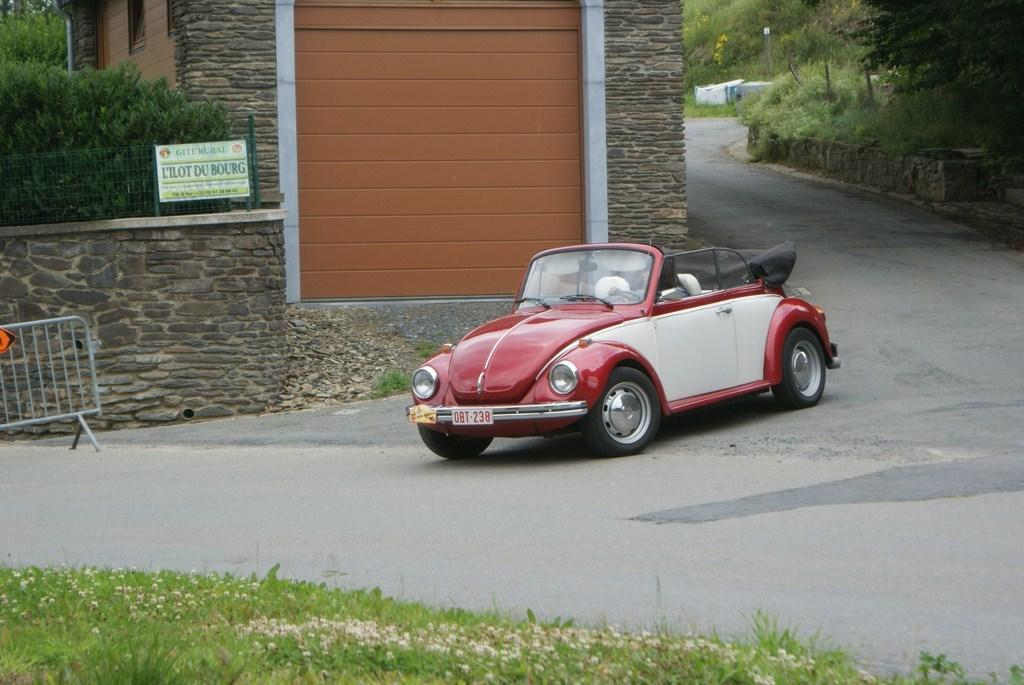What is the main subject of the image? There is a person in a vehicle in the image. What can be seen in the background of the image? There is a road, ground with grass, a wall, plants, and trees visible in the image. What is the purpose of the board with text in the image? The purpose of the board with text is not clear from the image, but it may be a sign or advertisement. What type of fencing is present in the image? There is fencing in the image, but the type of fencing is not specified. What object is located on the left side of the image? There is an object on the left side of the image, but its description is not provided. What type of shelf can be seen in the image? There is no shelf present in the image. How old is the daughter of the person in the vehicle? There is no daughter mentioned or visible in the image. 